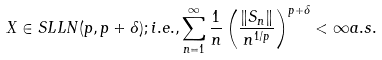<formula> <loc_0><loc_0><loc_500><loc_500>X \in S L L N ( p , p + \delta ) ; i . e . , \sum _ { n = 1 } ^ { \infty } \frac { 1 } { n } \left ( \frac { \| S _ { n } \| } { n ^ { 1 / p } } \right ) ^ { p + \delta } < \infty a . s .</formula> 